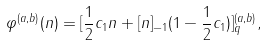Convert formula to latex. <formula><loc_0><loc_0><loc_500><loc_500>\varphi ^ { ( a , b ) } ( n ) = [ \frac { 1 } { 2 } c _ { 1 } n + [ n ] _ { - 1 } ( 1 - \frac { 1 } { 2 } c _ { 1 } ) ] ^ { ( a , b ) } _ { q } ,</formula> 